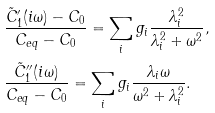Convert formula to latex. <formula><loc_0><loc_0><loc_500><loc_500>& \frac { \tilde { C } ^ { \prime } _ { 1 } ( i \omega ) - C _ { 0 } } { C _ { e q } - C _ { 0 } } = \sum _ { i } g _ { i } \frac { \lambda _ { i } ^ { 2 } } { \lambda _ { i } ^ { 2 } + \omega ^ { 2 } } , \\ & \frac { \tilde { C } ^ { \prime \prime } _ { 1 } ( i \omega ) } { C _ { e q } - C _ { 0 } } = \sum _ { i } g _ { i } \frac { \lambda _ { i } \omega } { \omega ^ { 2 } + \lambda _ { i } ^ { 2 } } .</formula> 